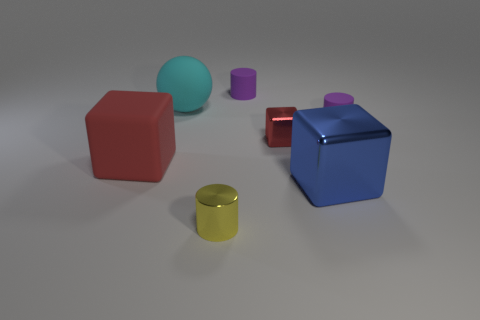The cyan thing has what size?
Your answer should be very brief. Large. The yellow thing has what shape?
Your answer should be very brief. Cylinder. There is a large rubber object to the left of the large ball; is it the same color as the small metallic cube?
Offer a very short reply. Yes. There is another red metallic thing that is the same shape as the big metal thing; what size is it?
Ensure brevity in your answer.  Small. Are there any large metal objects that are right of the tiny purple matte cylinder that is to the left of the tiny cylinder that is to the right of the tiny cube?
Ensure brevity in your answer.  Yes. What material is the block left of the big cyan sphere?
Give a very brief answer. Rubber. What number of tiny things are purple matte spheres or cyan things?
Ensure brevity in your answer.  0. There is a red cube behind the red rubber object; does it have the same size as the tiny yellow cylinder?
Give a very brief answer. Yes. How many other things are the same color as the matte ball?
Your answer should be compact. 0. What is the material of the large red thing?
Ensure brevity in your answer.  Rubber. 